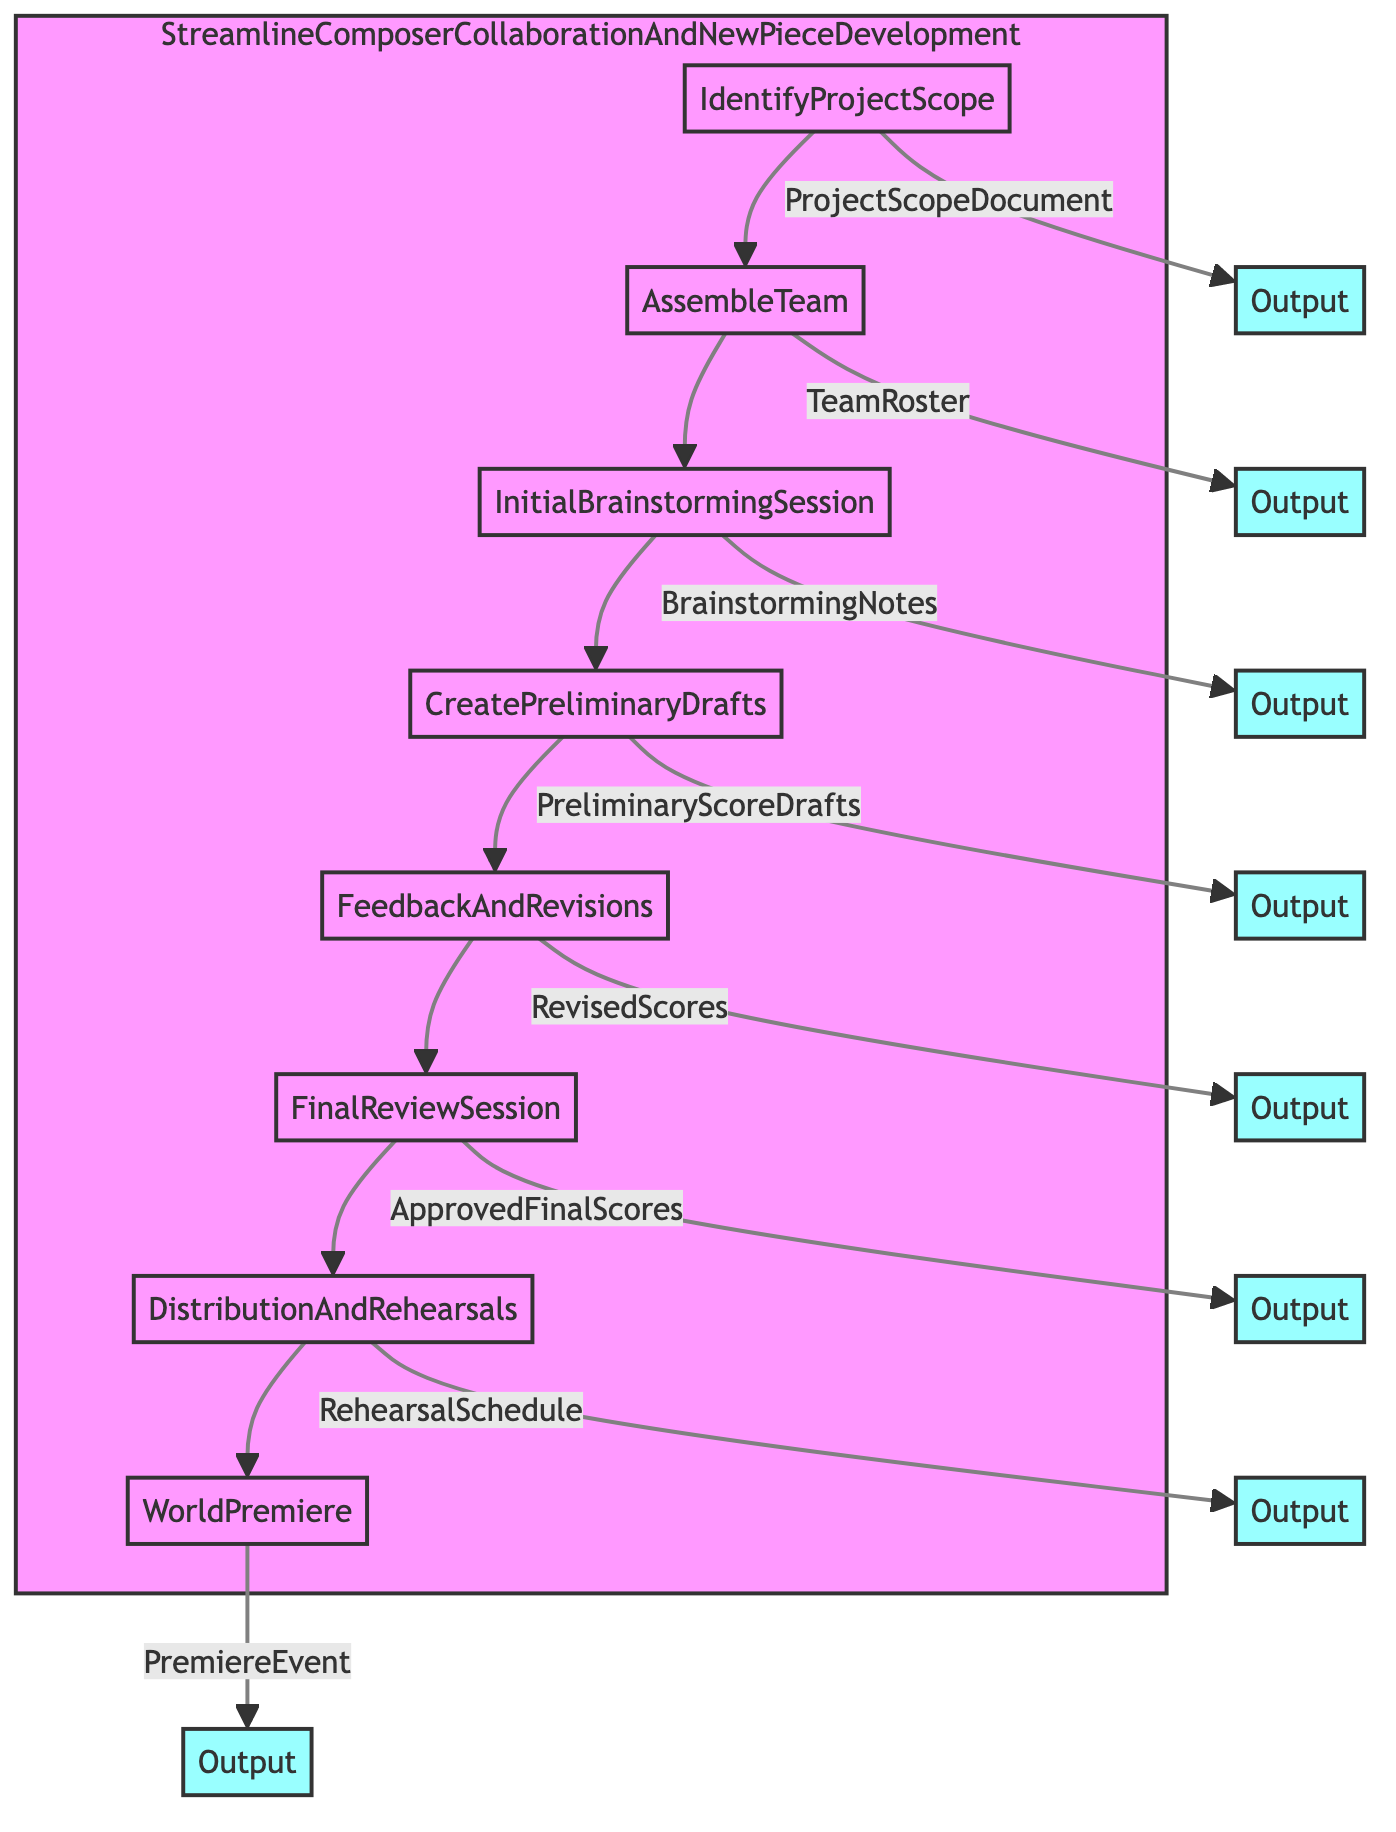What is the first step in the process? The first step, as indicated in the flowchart, is "IdentifyProjectScope." This establishes the foundation for the entire process of composer collaboration and new piece development.
Answer: IdentifyProjectScope Who are the entities involved in the Initial Brainstorming Session? According to the flowchart, the entities involved in the Initial Brainstorming Session are "Composer A, Composer B," and "Selected Musicians." These participants are essential for generating ideas collaboratively.
Answer: Composer A, Composer B, Selected Musicians What output is produced after the Final Review Session? After the Final Review Session, the output indicated in the flowchart is "ApprovedFinalScores." This output signifies that the musical scores have been finalized and approved.
Answer: ApprovedFinalScores How many total steps are listed in the diagram? The diagram includes a total of eight steps, each representing a distinct phase in the process of composer collaboration and new piece development.
Answer: 8 Which step directly follows the feedback and revisions? Based on the flowchart, the step that comes directly after "FeedbackAndRevisions" is "FinalReviewSession." This indicates that after receiving feedback, a final review is conducted.
Answer: FinalReviewSession What is the output of the Distribution and Rehearsals step? The flowchart indicates that the output of the Distribution and Rehearsals step is "RehearsalSchedule." This document helps coordinate the rehearsals with the ensemble.
Answer: RehearsalSchedule Which entities are involved in the final step of the process? The flowchart provides that the entities involved in the final step, "WorldPremiere," include "Event Planners," "Media Partners," and "Venue Management." These roles are crucial for executing the premiere performance.
Answer: Event Planners, Media Partners, Venue Management Which two steps are connected directly from "CreatePreliminaryDrafts"? The flowchart shows that "CreatePreliminaryDrafts" is directly connected to "FeedbackAndRevisions" as the subsequent step. This indicates that drafts must undergo feedback after creation.
Answer: FeedbackAndRevisions What step comes before the "AssembleTeam"? The flowchart indicates that the step preceding "AssembleTeam" is "IdentifyProjectScope." This demonstrates that defining the project scope is essential before assembling the collaboration team.
Answer: IdentifyProjectScope 